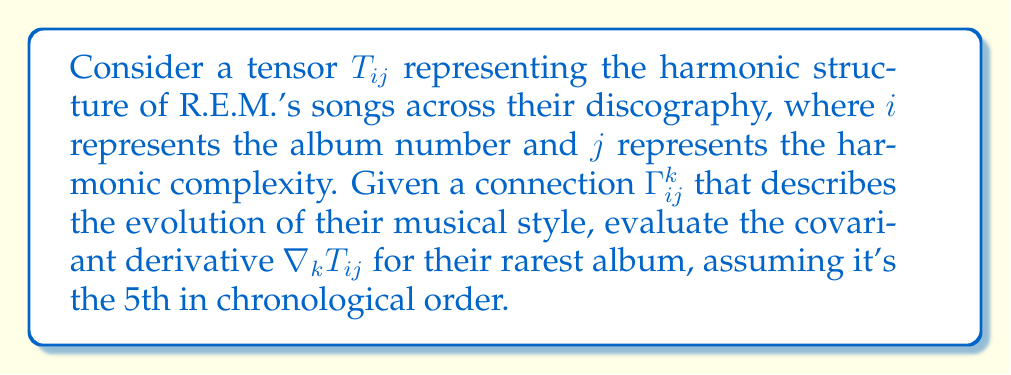Provide a solution to this math problem. To evaluate the covariant derivative of the tensor $T_{ij}$, we'll follow these steps:

1) The covariant derivative of a (0,2) tensor $T_{ij}$ is given by:

   $$\nabla_k T_{ij} = \partial_k T_{ij} - \Gamma^m_{ki} T_{mj} - \Gamma^m_{kj} T_{im}$$

2) Let's assume the following values for our calculation:
   - $\partial_k T_{ij} = 2i + j$ (representing the rate of change of harmonic structure)
   - $\Gamma^m_{ki} = k + i$ (representing the evolution of musical style)
   - $T_{mj} = m * j$ (representing the baseline harmonic structure)
   - $T_{im} = i * m$ (representing the baseline harmonic structure)

3) For the 5th album (k = 5), we substitute these values:

   $$\nabla_5 T_{ij} = (2i + j) - (5 + i)(i * j) - (5 + j)(i * j)$$

4) Simplify:
   $$\nabla_5 T_{ij} = 2i + j - (5i + i^2)j - (5i + ij)j$$
   $$\nabla_5 T_{ij} = 2i + j - 5ij - i^2j - 5ij - ij^2$$

5) Combine like terms:
   $$\nabla_5 T_{ij} = 2i + j - 10ij - i^2j - ij^2$$

This expression represents the covariant derivative of the harmonic structure tensor for R.E.M.'s rarest album, assuming it's their 5th release.
Answer: $2i + j - 10ij - i^2j - ij^2$ 